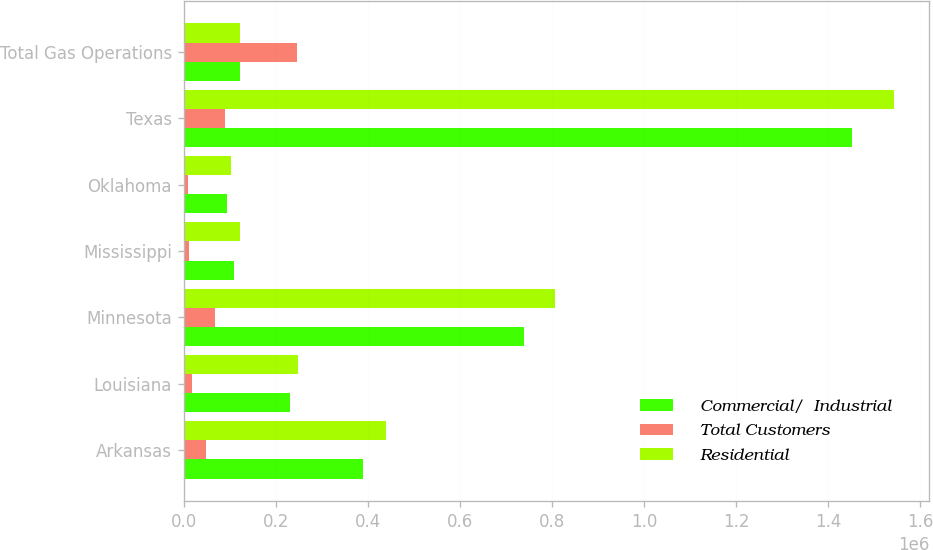Convert chart to OTSL. <chart><loc_0><loc_0><loc_500><loc_500><stacked_bar_chart><ecel><fcel>Arkansas<fcel>Louisiana<fcel>Minnesota<fcel>Mississippi<fcel>Oklahoma<fcel>Texas<fcel>Total Gas Operations<nl><fcel>Commercial/  Industrial<fcel>390668<fcel>232135<fcel>738868<fcel>109608<fcel>93388<fcel>1.45167e+06<fcel>122291<nl><fcel>Total Customers<fcel>48033<fcel>17347<fcel>67489<fcel>12683<fcel>10620<fcel>90719<fcel>246891<nl><fcel>Residential<fcel>438701<fcel>249482<fcel>806357<fcel>122291<fcel>104008<fcel>1.54238e+06<fcel>122291<nl></chart> 